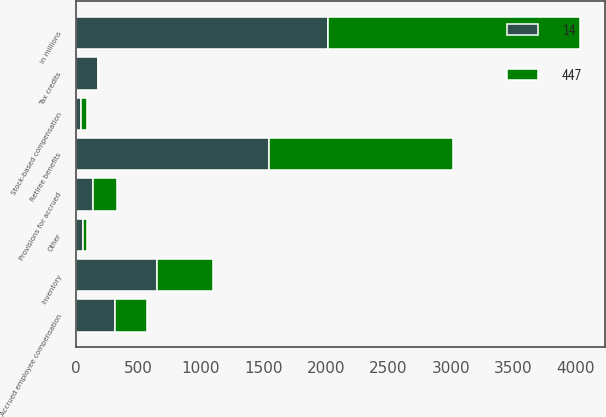Convert chart. <chart><loc_0><loc_0><loc_500><loc_500><stacked_bar_chart><ecel><fcel>in millions<fcel>Retiree benefits<fcel>Accrued employee compensation<fcel>Provisions for accrued<fcel>Inventory<fcel>Stock-based compensation<fcel>Tax credits<fcel>Other<nl><fcel>14<fcel>2018<fcel>1541<fcel>308<fcel>139<fcel>650<fcel>42<fcel>174<fcel>59<nl><fcel>447<fcel>2017<fcel>1477<fcel>263<fcel>193<fcel>447<fcel>46<fcel>9<fcel>30<nl></chart> 